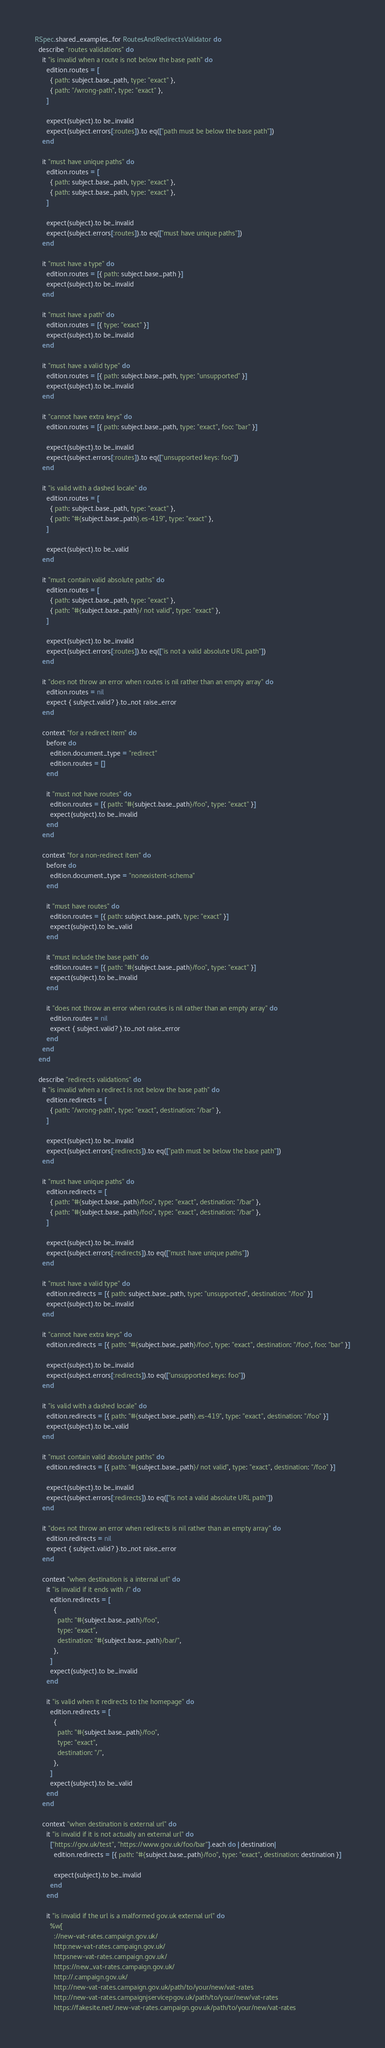Convert code to text. <code><loc_0><loc_0><loc_500><loc_500><_Ruby_>RSpec.shared_examples_for RoutesAndRedirectsValidator do
  describe "routes validations" do
    it "is invalid when a route is not below the base path" do
      edition.routes = [
        { path: subject.base_path, type: "exact" },
        { path: "/wrong-path", type: "exact" },
      ]

      expect(subject).to be_invalid
      expect(subject.errors[:routes]).to eq(["path must be below the base path"])
    end

    it "must have unique paths" do
      edition.routes = [
        { path: subject.base_path, type: "exact" },
        { path: subject.base_path, type: "exact" },
      ]

      expect(subject).to be_invalid
      expect(subject.errors[:routes]).to eq(["must have unique paths"])
    end

    it "must have a type" do
      edition.routes = [{ path: subject.base_path }]
      expect(subject).to be_invalid
    end

    it "must have a path" do
      edition.routes = [{ type: "exact" }]
      expect(subject).to be_invalid
    end

    it "must have a valid type" do
      edition.routes = [{ path: subject.base_path, type: "unsupported" }]
      expect(subject).to be_invalid
    end

    it "cannot have extra keys" do
      edition.routes = [{ path: subject.base_path, type: "exact", foo: "bar" }]

      expect(subject).to be_invalid
      expect(subject.errors[:routes]).to eq(["unsupported keys: foo"])
    end

    it "is valid with a dashed locale" do
      edition.routes = [
        { path: subject.base_path, type: "exact" },
        { path: "#{subject.base_path}.es-419", type: "exact" },
      ]

      expect(subject).to be_valid
    end

    it "must contain valid absolute paths" do
      edition.routes = [
        { path: subject.base_path, type: "exact" },
        { path: "#{subject.base_path}/ not valid", type: "exact" },
      ]

      expect(subject).to be_invalid
      expect(subject.errors[:routes]).to eq(["is not a valid absolute URL path"])
    end

    it "does not throw an error when routes is nil rather than an empty array" do
      edition.routes = nil
      expect { subject.valid? }.to_not raise_error
    end

    context "for a redirect item" do
      before do
        edition.document_type = "redirect"
        edition.routes = []
      end

      it "must not have routes" do
        edition.routes = [{ path: "#{subject.base_path}/foo", type: "exact" }]
        expect(subject).to be_invalid
      end
    end

    context "for a non-redirect item" do
      before do
        edition.document_type = "nonexistent-schema"
      end

      it "must have routes" do
        edition.routes = [{ path: subject.base_path, type: "exact" }]
        expect(subject).to be_valid
      end

      it "must include the base path" do
        edition.routes = [{ path: "#{subject.base_path}/foo", type: "exact" }]
        expect(subject).to be_invalid
      end

      it "does not throw an error when routes is nil rather than an empty array" do
        edition.routes = nil
        expect { subject.valid? }.to_not raise_error
      end
    end
  end

  describe "redirects validations" do
    it "is invalid when a redirect is not below the base path" do
      edition.redirects = [
        { path: "/wrong-path", type: "exact", destination: "/bar" },
      ]

      expect(subject).to be_invalid
      expect(subject.errors[:redirects]).to eq(["path must be below the base path"])
    end

    it "must have unique paths" do
      edition.redirects = [
        { path: "#{subject.base_path}/foo", type: "exact", destination: "/bar" },
        { path: "#{subject.base_path}/foo", type: "exact", destination: "/bar" },
      ]

      expect(subject).to be_invalid
      expect(subject.errors[:redirects]).to eq(["must have unique paths"])
    end

    it "must have a valid type" do
      edition.redirects = [{ path: subject.base_path, type: "unsupported", destination: "/foo" }]
      expect(subject).to be_invalid
    end

    it "cannot have extra keys" do
      edition.redirects = [{ path: "#{subject.base_path}/foo", type: "exact", destination: "/foo", foo: "bar" }]

      expect(subject).to be_invalid
      expect(subject.errors[:redirects]).to eq(["unsupported keys: foo"])
    end

    it "is valid with a dashed locale" do
      edition.redirects = [{ path: "#{subject.base_path}.es-419", type: "exact", destination: "/foo" }]
      expect(subject).to be_valid
    end

    it "must contain valid absolute paths" do
      edition.redirects = [{ path: "#{subject.base_path}/ not valid", type: "exact", destination: "/foo" }]

      expect(subject).to be_invalid
      expect(subject.errors[:redirects]).to eq(["is not a valid absolute URL path"])
    end

    it "does not throw an error when redirects is nil rather than an empty array" do
      edition.redirects = nil
      expect { subject.valid? }.to_not raise_error
    end

    context "when destination is a internal url" do
      it "is invalid if it ends with /" do
        edition.redirects = [
          {
            path: "#{subject.base_path}/foo",
            type: "exact",
            destination: "#{subject.base_path}/bar/",
          },
        ]
        expect(subject).to be_invalid
      end

      it "is valid when it redirects to the homepage" do
        edition.redirects = [
          {
            path: "#{subject.base_path}/foo",
            type: "exact",
            destination: "/",
          },
        ]
        expect(subject).to be_valid
      end
    end

    context "when destination is external url" do
      it "is invalid if it is not actually an external url" do
        ["https://gov.uk/test", "https://www.gov.uk/foo/bar"].each do |destination|
          edition.redirects = [{ path: "#{subject.base_path}/foo", type: "exact", destination: destination }]

          expect(subject).to be_invalid
        end
      end

      it "is invalid if the url is a malformed gov.uk external url" do
        %w[
          ://new-vat-rates.campaign.gov.uk/
          http:new-vat-rates.campaign.gov.uk/
          httpsnew-vat-rates.campaign.gov.uk/
          https://new_vat-rates.campaign.gov.uk/
          http://.campaign.gov.uk/
          http://new-vat-rates.campaign.gov.uk/path/to/your/new/vat-rates
          http://new-vat-rates.campaignjservicepgov.uk/path/to/your/new/vat-rates
          https://fakesite.net/.new-vat-rates.campaign.gov.uk/path/to/your/new/vat-rates</code> 